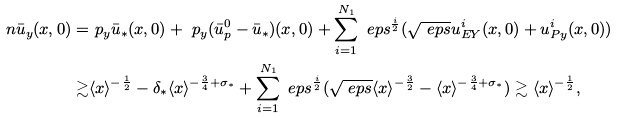Convert formula to latex. <formula><loc_0><loc_0><loc_500><loc_500>\ n \bar { u } _ { y } ( x , 0 ) = & \ p _ { y } \bar { u } _ { \ast } ( x , 0 ) + \ p _ { y } ( \bar { u } ^ { 0 } _ { p } - \bar { u } _ { \ast } ) ( x , 0 ) + \sum _ { i = 1 } ^ { N _ { 1 } } \ e p s ^ { \frac { i } { 2 } } ( \sqrt { \ e p s } u ^ { i } _ { E Y } ( x , 0 ) + u ^ { i } _ { P y } ( x , 0 ) ) \\ \gtrsim & \langle x \rangle ^ { - \frac { 1 } { 2 } } - \delta _ { \ast } \langle x \rangle ^ { - \frac { 3 } { 4 } + \sigma _ { \ast } } + \sum _ { i = 1 } ^ { N _ { 1 } } \ e p s ^ { \frac { i } { 2 } } ( \sqrt { \ e p s } \langle x \rangle ^ { - \frac { 3 } { 2 } } - \langle x \rangle ^ { - \frac { 3 } { 4 } + \sigma _ { \ast } } ) \gtrsim \langle x \rangle ^ { - \frac { 1 } { 2 } } ,</formula> 